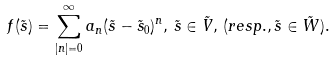<formula> <loc_0><loc_0><loc_500><loc_500>f ( \tilde { s } ) = \sum _ { | n | = 0 } ^ { \infty } a _ { n } ( \tilde { s } - \tilde { s } _ { 0 } ) ^ { n } , \, \tilde { s } \in \tilde { V } , \, ( r e s p . , \tilde { s } \in \tilde { W } ) .</formula> 